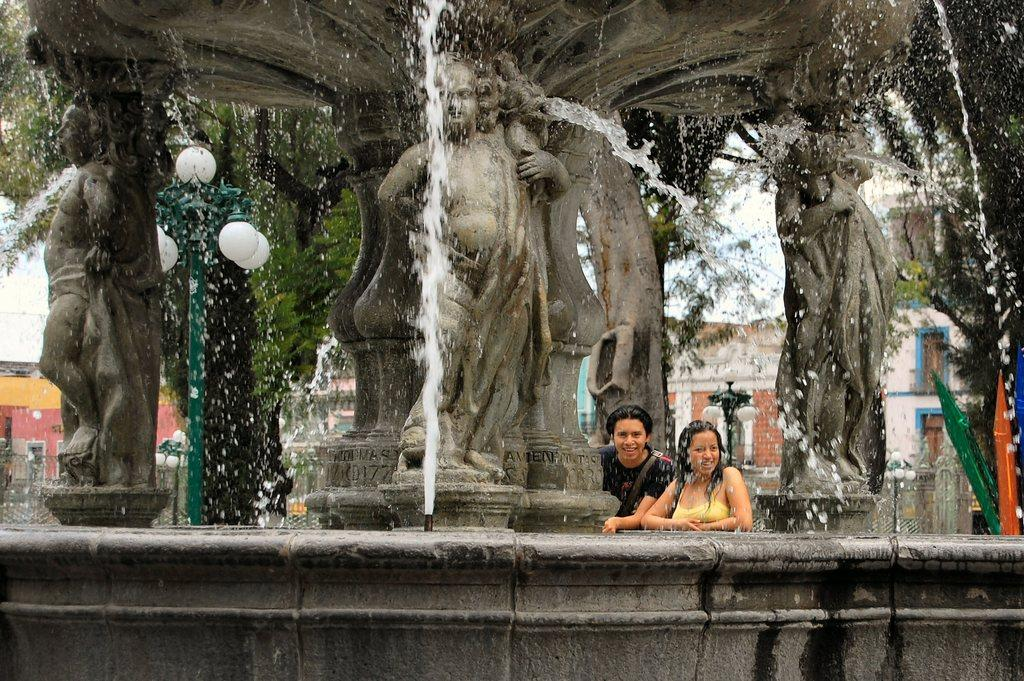What type of objects can be seen in the image? There are statues in the image. What natural element is visible in the image? There is water visible in the image. What living beings are present in the image? There are humans standing in the image. What type of lighting is present in the image? Pole lights are present in the image. What type of vegetation is visible in the image? Trees are visible in the image. What type of structures can be seen in the background of the image? There are buildings in the background of the image. Can you tell me how many actors are performing in the image? There is no reference to actors or a performance in the image; it features statues, water, humans, pole lights, trees, and buildings. What type of bird can be seen flying in the image? There are no birds visible in the image. 